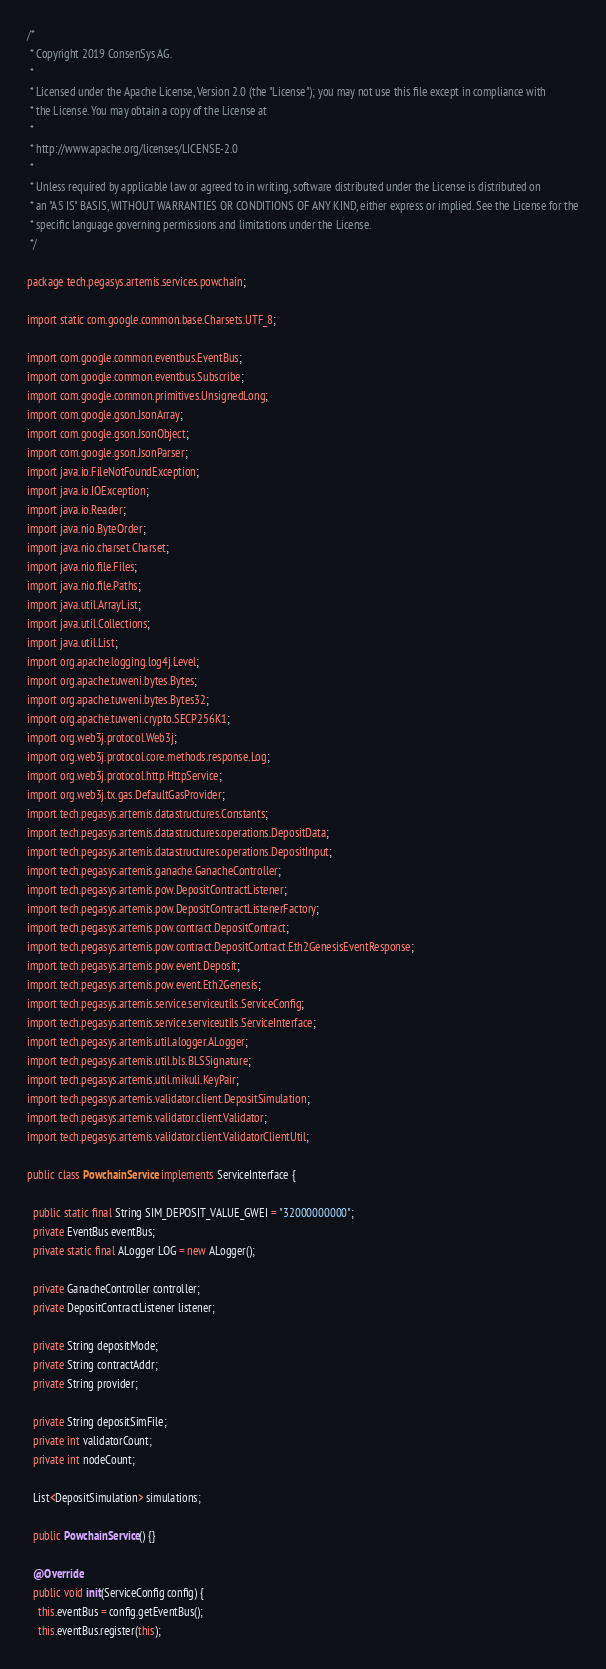Convert code to text. <code><loc_0><loc_0><loc_500><loc_500><_Java_>/*
 * Copyright 2019 ConsenSys AG.
 *
 * Licensed under the Apache License, Version 2.0 (the "License"); you may not use this file except in compliance with
 * the License. You may obtain a copy of the License at
 *
 * http://www.apache.org/licenses/LICENSE-2.0
 *
 * Unless required by applicable law or agreed to in writing, software distributed under the License is distributed on
 * an "AS IS" BASIS, WITHOUT WARRANTIES OR CONDITIONS OF ANY KIND, either express or implied. See the License for the
 * specific language governing permissions and limitations under the License.
 */

package tech.pegasys.artemis.services.powchain;

import static com.google.common.base.Charsets.UTF_8;

import com.google.common.eventbus.EventBus;
import com.google.common.eventbus.Subscribe;
import com.google.common.primitives.UnsignedLong;
import com.google.gson.JsonArray;
import com.google.gson.JsonObject;
import com.google.gson.JsonParser;
import java.io.FileNotFoundException;
import java.io.IOException;
import java.io.Reader;
import java.nio.ByteOrder;
import java.nio.charset.Charset;
import java.nio.file.Files;
import java.nio.file.Paths;
import java.util.ArrayList;
import java.util.Collections;
import java.util.List;
import org.apache.logging.log4j.Level;
import org.apache.tuweni.bytes.Bytes;
import org.apache.tuweni.bytes.Bytes32;
import org.apache.tuweni.crypto.SECP256K1;
import org.web3j.protocol.Web3j;
import org.web3j.protocol.core.methods.response.Log;
import org.web3j.protocol.http.HttpService;
import org.web3j.tx.gas.DefaultGasProvider;
import tech.pegasys.artemis.datastructures.Constants;
import tech.pegasys.artemis.datastructures.operations.DepositData;
import tech.pegasys.artemis.datastructures.operations.DepositInput;
import tech.pegasys.artemis.ganache.GanacheController;
import tech.pegasys.artemis.pow.DepositContractListener;
import tech.pegasys.artemis.pow.DepositContractListenerFactory;
import tech.pegasys.artemis.pow.contract.DepositContract;
import tech.pegasys.artemis.pow.contract.DepositContract.Eth2GenesisEventResponse;
import tech.pegasys.artemis.pow.event.Deposit;
import tech.pegasys.artemis.pow.event.Eth2Genesis;
import tech.pegasys.artemis.service.serviceutils.ServiceConfig;
import tech.pegasys.artemis.service.serviceutils.ServiceInterface;
import tech.pegasys.artemis.util.alogger.ALogger;
import tech.pegasys.artemis.util.bls.BLSSignature;
import tech.pegasys.artemis.util.mikuli.KeyPair;
import tech.pegasys.artemis.validator.client.DepositSimulation;
import tech.pegasys.artemis.validator.client.Validator;
import tech.pegasys.artemis.validator.client.ValidatorClientUtil;

public class PowchainService implements ServiceInterface {

  public static final String SIM_DEPOSIT_VALUE_GWEI = "32000000000";
  private EventBus eventBus;
  private static final ALogger LOG = new ALogger();

  private GanacheController controller;
  private DepositContractListener listener;

  private String depositMode;
  private String contractAddr;
  private String provider;

  private String depositSimFile;
  private int validatorCount;
  private int nodeCount;

  List<DepositSimulation> simulations;

  public PowchainService() {}

  @Override
  public void init(ServiceConfig config) {
    this.eventBus = config.getEventBus();
    this.eventBus.register(this);</code> 